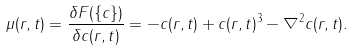<formula> <loc_0><loc_0><loc_500><loc_500>\mu ( { r } , t ) = \frac { \delta F ( \{ c \} ) } { \delta c ( { r } , t ) } = - c ( { r } , t ) + c ( { r } , t ) ^ { 3 } - \nabla ^ { 2 } c ( { r } , t ) .</formula> 